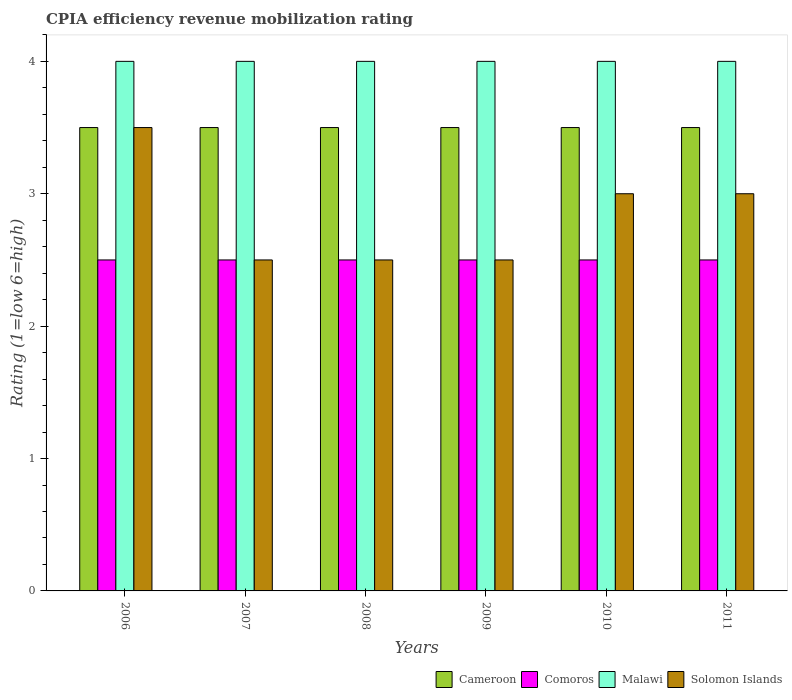Are the number of bars per tick equal to the number of legend labels?
Provide a short and direct response. Yes. Are the number of bars on each tick of the X-axis equal?
Offer a terse response. Yes. What is the label of the 1st group of bars from the left?
Ensure brevity in your answer.  2006. Across all years, what is the maximum CPIA rating in Comoros?
Your answer should be compact. 2.5. Across all years, what is the minimum CPIA rating in Malawi?
Give a very brief answer. 4. In which year was the CPIA rating in Malawi maximum?
Give a very brief answer. 2006. In which year was the CPIA rating in Cameroon minimum?
Keep it short and to the point. 2006. What is the total CPIA rating in Solomon Islands in the graph?
Your answer should be compact. 17. What is the difference between the CPIA rating in Cameroon in 2008 and that in 2011?
Your answer should be compact. 0. What is the difference between the CPIA rating in Comoros in 2011 and the CPIA rating in Cameroon in 2007?
Your response must be concise. -1. What is the ratio of the CPIA rating in Solomon Islands in 2006 to that in 2010?
Your answer should be very brief. 1.17. Is the difference between the CPIA rating in Solomon Islands in 2006 and 2007 greater than the difference between the CPIA rating in Cameroon in 2006 and 2007?
Your response must be concise. Yes. What is the difference between the highest and the lowest CPIA rating in Comoros?
Offer a very short reply. 0. Is the sum of the CPIA rating in Comoros in 2008 and 2010 greater than the maximum CPIA rating in Malawi across all years?
Give a very brief answer. Yes. What does the 2nd bar from the left in 2010 represents?
Offer a very short reply. Comoros. What does the 4th bar from the right in 2008 represents?
Your answer should be very brief. Cameroon. Is it the case that in every year, the sum of the CPIA rating in Comoros and CPIA rating in Malawi is greater than the CPIA rating in Cameroon?
Offer a terse response. Yes. Are all the bars in the graph horizontal?
Your answer should be very brief. No. How many years are there in the graph?
Provide a short and direct response. 6. Does the graph contain any zero values?
Make the answer very short. No. Does the graph contain grids?
Give a very brief answer. No. Where does the legend appear in the graph?
Keep it short and to the point. Bottom right. How are the legend labels stacked?
Make the answer very short. Horizontal. What is the title of the graph?
Keep it short and to the point. CPIA efficiency revenue mobilization rating. What is the Rating (1=low 6=high) of Cameroon in 2006?
Your response must be concise. 3.5. What is the Rating (1=low 6=high) in Solomon Islands in 2006?
Your response must be concise. 3.5. What is the Rating (1=low 6=high) in Cameroon in 2008?
Provide a succinct answer. 3.5. What is the Rating (1=low 6=high) in Comoros in 2008?
Provide a succinct answer. 2.5. What is the Rating (1=low 6=high) in Solomon Islands in 2008?
Keep it short and to the point. 2.5. What is the Rating (1=low 6=high) in Comoros in 2009?
Your response must be concise. 2.5. What is the Rating (1=low 6=high) of Solomon Islands in 2009?
Keep it short and to the point. 2.5. What is the Rating (1=low 6=high) of Comoros in 2010?
Offer a very short reply. 2.5. What is the Rating (1=low 6=high) of Solomon Islands in 2010?
Keep it short and to the point. 3. What is the Rating (1=low 6=high) of Comoros in 2011?
Provide a succinct answer. 2.5. What is the Rating (1=low 6=high) in Malawi in 2011?
Your answer should be very brief. 4. What is the Rating (1=low 6=high) of Solomon Islands in 2011?
Your answer should be very brief. 3. Across all years, what is the maximum Rating (1=low 6=high) in Malawi?
Your answer should be compact. 4. Across all years, what is the maximum Rating (1=low 6=high) of Solomon Islands?
Offer a terse response. 3.5. Across all years, what is the minimum Rating (1=low 6=high) in Cameroon?
Give a very brief answer. 3.5. Across all years, what is the minimum Rating (1=low 6=high) of Malawi?
Make the answer very short. 4. Across all years, what is the minimum Rating (1=low 6=high) in Solomon Islands?
Offer a very short reply. 2.5. What is the total Rating (1=low 6=high) in Malawi in the graph?
Offer a terse response. 24. What is the total Rating (1=low 6=high) of Solomon Islands in the graph?
Your answer should be compact. 17. What is the difference between the Rating (1=low 6=high) in Cameroon in 2006 and that in 2007?
Your answer should be compact. 0. What is the difference between the Rating (1=low 6=high) of Comoros in 2006 and that in 2007?
Your answer should be very brief. 0. What is the difference between the Rating (1=low 6=high) in Malawi in 2006 and that in 2007?
Offer a terse response. 0. What is the difference between the Rating (1=low 6=high) of Cameroon in 2006 and that in 2008?
Offer a very short reply. 0. What is the difference between the Rating (1=low 6=high) in Comoros in 2006 and that in 2008?
Offer a very short reply. 0. What is the difference between the Rating (1=low 6=high) in Malawi in 2006 and that in 2008?
Your answer should be compact. 0. What is the difference between the Rating (1=low 6=high) of Solomon Islands in 2006 and that in 2008?
Your answer should be very brief. 1. What is the difference between the Rating (1=low 6=high) in Comoros in 2006 and that in 2010?
Make the answer very short. 0. What is the difference between the Rating (1=low 6=high) of Malawi in 2006 and that in 2010?
Ensure brevity in your answer.  0. What is the difference between the Rating (1=low 6=high) in Comoros in 2006 and that in 2011?
Ensure brevity in your answer.  0. What is the difference between the Rating (1=low 6=high) in Malawi in 2006 and that in 2011?
Make the answer very short. 0. What is the difference between the Rating (1=low 6=high) of Malawi in 2007 and that in 2008?
Ensure brevity in your answer.  0. What is the difference between the Rating (1=low 6=high) of Solomon Islands in 2007 and that in 2008?
Give a very brief answer. 0. What is the difference between the Rating (1=low 6=high) in Solomon Islands in 2007 and that in 2009?
Your response must be concise. 0. What is the difference between the Rating (1=low 6=high) of Comoros in 2007 and that in 2010?
Give a very brief answer. 0. What is the difference between the Rating (1=low 6=high) of Malawi in 2007 and that in 2010?
Offer a terse response. 0. What is the difference between the Rating (1=low 6=high) in Cameroon in 2007 and that in 2011?
Make the answer very short. 0. What is the difference between the Rating (1=low 6=high) in Comoros in 2007 and that in 2011?
Offer a very short reply. 0. What is the difference between the Rating (1=low 6=high) of Malawi in 2007 and that in 2011?
Your response must be concise. 0. What is the difference between the Rating (1=low 6=high) in Cameroon in 2008 and that in 2010?
Make the answer very short. 0. What is the difference between the Rating (1=low 6=high) in Comoros in 2008 and that in 2010?
Offer a very short reply. 0. What is the difference between the Rating (1=low 6=high) in Solomon Islands in 2008 and that in 2010?
Offer a very short reply. -0.5. What is the difference between the Rating (1=low 6=high) in Cameroon in 2008 and that in 2011?
Make the answer very short. 0. What is the difference between the Rating (1=low 6=high) in Comoros in 2008 and that in 2011?
Your answer should be very brief. 0. What is the difference between the Rating (1=low 6=high) in Solomon Islands in 2008 and that in 2011?
Keep it short and to the point. -0.5. What is the difference between the Rating (1=low 6=high) in Malawi in 2009 and that in 2010?
Keep it short and to the point. 0. What is the difference between the Rating (1=low 6=high) in Cameroon in 2009 and that in 2011?
Make the answer very short. 0. What is the difference between the Rating (1=low 6=high) of Comoros in 2010 and that in 2011?
Ensure brevity in your answer.  0. What is the difference between the Rating (1=low 6=high) in Malawi in 2010 and that in 2011?
Provide a short and direct response. 0. What is the difference between the Rating (1=low 6=high) in Cameroon in 2006 and the Rating (1=low 6=high) in Malawi in 2007?
Your answer should be compact. -0.5. What is the difference between the Rating (1=low 6=high) in Comoros in 2006 and the Rating (1=low 6=high) in Malawi in 2007?
Make the answer very short. -1.5. What is the difference between the Rating (1=low 6=high) of Comoros in 2006 and the Rating (1=low 6=high) of Solomon Islands in 2007?
Provide a succinct answer. 0. What is the difference between the Rating (1=low 6=high) in Cameroon in 2006 and the Rating (1=low 6=high) in Comoros in 2008?
Offer a very short reply. 1. What is the difference between the Rating (1=low 6=high) of Cameroon in 2006 and the Rating (1=low 6=high) of Malawi in 2008?
Keep it short and to the point. -0.5. What is the difference between the Rating (1=low 6=high) in Cameroon in 2006 and the Rating (1=low 6=high) in Solomon Islands in 2008?
Ensure brevity in your answer.  1. What is the difference between the Rating (1=low 6=high) of Comoros in 2006 and the Rating (1=low 6=high) of Malawi in 2008?
Your response must be concise. -1.5. What is the difference between the Rating (1=low 6=high) of Comoros in 2006 and the Rating (1=low 6=high) of Solomon Islands in 2008?
Make the answer very short. 0. What is the difference between the Rating (1=low 6=high) of Malawi in 2006 and the Rating (1=low 6=high) of Solomon Islands in 2008?
Keep it short and to the point. 1.5. What is the difference between the Rating (1=low 6=high) in Cameroon in 2006 and the Rating (1=low 6=high) in Malawi in 2009?
Offer a terse response. -0.5. What is the difference between the Rating (1=low 6=high) of Cameroon in 2006 and the Rating (1=low 6=high) of Solomon Islands in 2009?
Offer a very short reply. 1. What is the difference between the Rating (1=low 6=high) in Comoros in 2006 and the Rating (1=low 6=high) in Solomon Islands in 2009?
Offer a very short reply. 0. What is the difference between the Rating (1=low 6=high) of Cameroon in 2006 and the Rating (1=low 6=high) of Comoros in 2010?
Your response must be concise. 1. What is the difference between the Rating (1=low 6=high) in Cameroon in 2006 and the Rating (1=low 6=high) in Malawi in 2010?
Provide a succinct answer. -0.5. What is the difference between the Rating (1=low 6=high) in Comoros in 2006 and the Rating (1=low 6=high) in Solomon Islands in 2010?
Make the answer very short. -0.5. What is the difference between the Rating (1=low 6=high) in Malawi in 2006 and the Rating (1=low 6=high) in Solomon Islands in 2010?
Keep it short and to the point. 1. What is the difference between the Rating (1=low 6=high) of Cameroon in 2006 and the Rating (1=low 6=high) of Comoros in 2011?
Provide a short and direct response. 1. What is the difference between the Rating (1=low 6=high) of Cameroon in 2006 and the Rating (1=low 6=high) of Solomon Islands in 2011?
Provide a short and direct response. 0.5. What is the difference between the Rating (1=low 6=high) of Comoros in 2006 and the Rating (1=low 6=high) of Malawi in 2011?
Your answer should be compact. -1.5. What is the difference between the Rating (1=low 6=high) of Malawi in 2006 and the Rating (1=low 6=high) of Solomon Islands in 2011?
Provide a succinct answer. 1. What is the difference between the Rating (1=low 6=high) in Cameroon in 2007 and the Rating (1=low 6=high) in Malawi in 2008?
Keep it short and to the point. -0.5. What is the difference between the Rating (1=low 6=high) of Cameroon in 2007 and the Rating (1=low 6=high) of Solomon Islands in 2008?
Your answer should be compact. 1. What is the difference between the Rating (1=low 6=high) of Comoros in 2007 and the Rating (1=low 6=high) of Malawi in 2008?
Offer a very short reply. -1.5. What is the difference between the Rating (1=low 6=high) of Malawi in 2007 and the Rating (1=low 6=high) of Solomon Islands in 2008?
Your answer should be compact. 1.5. What is the difference between the Rating (1=low 6=high) in Cameroon in 2007 and the Rating (1=low 6=high) in Comoros in 2009?
Make the answer very short. 1. What is the difference between the Rating (1=low 6=high) in Cameroon in 2007 and the Rating (1=low 6=high) in Malawi in 2009?
Give a very brief answer. -0.5. What is the difference between the Rating (1=low 6=high) in Cameroon in 2007 and the Rating (1=low 6=high) in Solomon Islands in 2009?
Your answer should be very brief. 1. What is the difference between the Rating (1=low 6=high) in Comoros in 2007 and the Rating (1=low 6=high) in Malawi in 2009?
Give a very brief answer. -1.5. What is the difference between the Rating (1=low 6=high) in Comoros in 2007 and the Rating (1=low 6=high) in Solomon Islands in 2009?
Keep it short and to the point. 0. What is the difference between the Rating (1=low 6=high) in Malawi in 2007 and the Rating (1=low 6=high) in Solomon Islands in 2009?
Your response must be concise. 1.5. What is the difference between the Rating (1=low 6=high) in Cameroon in 2007 and the Rating (1=low 6=high) in Malawi in 2010?
Your answer should be very brief. -0.5. What is the difference between the Rating (1=low 6=high) of Cameroon in 2007 and the Rating (1=low 6=high) of Solomon Islands in 2010?
Your answer should be very brief. 0.5. What is the difference between the Rating (1=low 6=high) of Comoros in 2007 and the Rating (1=low 6=high) of Malawi in 2010?
Your answer should be compact. -1.5. What is the difference between the Rating (1=low 6=high) of Comoros in 2007 and the Rating (1=low 6=high) of Solomon Islands in 2010?
Offer a terse response. -0.5. What is the difference between the Rating (1=low 6=high) in Malawi in 2007 and the Rating (1=low 6=high) in Solomon Islands in 2010?
Your answer should be compact. 1. What is the difference between the Rating (1=low 6=high) in Cameroon in 2007 and the Rating (1=low 6=high) in Comoros in 2011?
Your answer should be compact. 1. What is the difference between the Rating (1=low 6=high) in Cameroon in 2007 and the Rating (1=low 6=high) in Solomon Islands in 2011?
Your response must be concise. 0.5. What is the difference between the Rating (1=low 6=high) of Comoros in 2007 and the Rating (1=low 6=high) of Solomon Islands in 2011?
Your answer should be very brief. -0.5. What is the difference between the Rating (1=low 6=high) in Cameroon in 2008 and the Rating (1=low 6=high) in Comoros in 2009?
Provide a succinct answer. 1. What is the difference between the Rating (1=low 6=high) of Cameroon in 2008 and the Rating (1=low 6=high) of Malawi in 2009?
Your response must be concise. -0.5. What is the difference between the Rating (1=low 6=high) in Comoros in 2008 and the Rating (1=low 6=high) in Malawi in 2009?
Your answer should be very brief. -1.5. What is the difference between the Rating (1=low 6=high) in Cameroon in 2008 and the Rating (1=low 6=high) in Malawi in 2010?
Offer a terse response. -0.5. What is the difference between the Rating (1=low 6=high) of Comoros in 2008 and the Rating (1=low 6=high) of Malawi in 2010?
Offer a terse response. -1.5. What is the difference between the Rating (1=low 6=high) in Cameroon in 2008 and the Rating (1=low 6=high) in Malawi in 2011?
Provide a succinct answer. -0.5. What is the difference between the Rating (1=low 6=high) of Comoros in 2008 and the Rating (1=low 6=high) of Solomon Islands in 2011?
Offer a very short reply. -0.5. What is the difference between the Rating (1=low 6=high) in Cameroon in 2009 and the Rating (1=low 6=high) in Comoros in 2010?
Make the answer very short. 1. What is the difference between the Rating (1=low 6=high) of Cameroon in 2009 and the Rating (1=low 6=high) of Malawi in 2010?
Provide a short and direct response. -0.5. What is the difference between the Rating (1=low 6=high) in Comoros in 2009 and the Rating (1=low 6=high) in Malawi in 2010?
Your answer should be compact. -1.5. What is the difference between the Rating (1=low 6=high) of Cameroon in 2009 and the Rating (1=low 6=high) of Comoros in 2011?
Offer a terse response. 1. What is the difference between the Rating (1=low 6=high) of Cameroon in 2009 and the Rating (1=low 6=high) of Solomon Islands in 2011?
Provide a short and direct response. 0.5. What is the difference between the Rating (1=low 6=high) of Comoros in 2009 and the Rating (1=low 6=high) of Malawi in 2011?
Ensure brevity in your answer.  -1.5. What is the difference between the Rating (1=low 6=high) in Comoros in 2009 and the Rating (1=low 6=high) in Solomon Islands in 2011?
Offer a terse response. -0.5. What is the difference between the Rating (1=low 6=high) of Cameroon in 2010 and the Rating (1=low 6=high) of Solomon Islands in 2011?
Keep it short and to the point. 0.5. What is the difference between the Rating (1=low 6=high) in Comoros in 2010 and the Rating (1=low 6=high) in Malawi in 2011?
Make the answer very short. -1.5. What is the difference between the Rating (1=low 6=high) in Malawi in 2010 and the Rating (1=low 6=high) in Solomon Islands in 2011?
Offer a very short reply. 1. What is the average Rating (1=low 6=high) of Malawi per year?
Provide a short and direct response. 4. What is the average Rating (1=low 6=high) of Solomon Islands per year?
Make the answer very short. 2.83. In the year 2006, what is the difference between the Rating (1=low 6=high) of Cameroon and Rating (1=low 6=high) of Solomon Islands?
Offer a terse response. 0. In the year 2006, what is the difference between the Rating (1=low 6=high) in Malawi and Rating (1=low 6=high) in Solomon Islands?
Offer a terse response. 0.5. In the year 2007, what is the difference between the Rating (1=low 6=high) in Cameroon and Rating (1=low 6=high) in Comoros?
Offer a terse response. 1. In the year 2007, what is the difference between the Rating (1=low 6=high) in Cameroon and Rating (1=low 6=high) in Solomon Islands?
Ensure brevity in your answer.  1. In the year 2007, what is the difference between the Rating (1=low 6=high) of Comoros and Rating (1=low 6=high) of Solomon Islands?
Give a very brief answer. 0. In the year 2008, what is the difference between the Rating (1=low 6=high) in Cameroon and Rating (1=low 6=high) in Comoros?
Provide a short and direct response. 1. In the year 2008, what is the difference between the Rating (1=low 6=high) of Cameroon and Rating (1=low 6=high) of Solomon Islands?
Offer a very short reply. 1. In the year 2008, what is the difference between the Rating (1=low 6=high) of Comoros and Rating (1=low 6=high) of Solomon Islands?
Your answer should be compact. 0. In the year 2009, what is the difference between the Rating (1=low 6=high) of Cameroon and Rating (1=low 6=high) of Solomon Islands?
Provide a succinct answer. 1. In the year 2009, what is the difference between the Rating (1=low 6=high) of Comoros and Rating (1=low 6=high) of Malawi?
Offer a very short reply. -1.5. In the year 2009, what is the difference between the Rating (1=low 6=high) in Malawi and Rating (1=low 6=high) in Solomon Islands?
Give a very brief answer. 1.5. In the year 2010, what is the difference between the Rating (1=low 6=high) in Cameroon and Rating (1=low 6=high) in Malawi?
Your answer should be compact. -0.5. In the year 2010, what is the difference between the Rating (1=low 6=high) in Comoros and Rating (1=low 6=high) in Malawi?
Offer a terse response. -1.5. In the year 2010, what is the difference between the Rating (1=low 6=high) of Comoros and Rating (1=low 6=high) of Solomon Islands?
Your answer should be very brief. -0.5. In the year 2011, what is the difference between the Rating (1=low 6=high) of Cameroon and Rating (1=low 6=high) of Malawi?
Make the answer very short. -0.5. In the year 2011, what is the difference between the Rating (1=low 6=high) of Comoros and Rating (1=low 6=high) of Solomon Islands?
Provide a succinct answer. -0.5. What is the ratio of the Rating (1=low 6=high) of Cameroon in 2006 to that in 2007?
Your answer should be very brief. 1. What is the ratio of the Rating (1=low 6=high) of Comoros in 2006 to that in 2007?
Keep it short and to the point. 1. What is the ratio of the Rating (1=low 6=high) in Malawi in 2006 to that in 2007?
Your response must be concise. 1. What is the ratio of the Rating (1=low 6=high) of Comoros in 2006 to that in 2008?
Give a very brief answer. 1. What is the ratio of the Rating (1=low 6=high) in Malawi in 2006 to that in 2009?
Keep it short and to the point. 1. What is the ratio of the Rating (1=low 6=high) of Solomon Islands in 2006 to that in 2009?
Your response must be concise. 1.4. What is the ratio of the Rating (1=low 6=high) of Cameroon in 2006 to that in 2010?
Make the answer very short. 1. What is the ratio of the Rating (1=low 6=high) in Malawi in 2006 to that in 2010?
Provide a succinct answer. 1. What is the ratio of the Rating (1=low 6=high) in Solomon Islands in 2006 to that in 2010?
Make the answer very short. 1.17. What is the ratio of the Rating (1=low 6=high) in Comoros in 2006 to that in 2011?
Make the answer very short. 1. What is the ratio of the Rating (1=low 6=high) of Solomon Islands in 2006 to that in 2011?
Offer a terse response. 1.17. What is the ratio of the Rating (1=low 6=high) of Comoros in 2007 to that in 2008?
Your answer should be very brief. 1. What is the ratio of the Rating (1=low 6=high) in Malawi in 2007 to that in 2008?
Your response must be concise. 1. What is the ratio of the Rating (1=low 6=high) in Solomon Islands in 2007 to that in 2008?
Offer a terse response. 1. What is the ratio of the Rating (1=low 6=high) in Comoros in 2007 to that in 2009?
Offer a terse response. 1. What is the ratio of the Rating (1=low 6=high) in Cameroon in 2007 to that in 2010?
Offer a very short reply. 1. What is the ratio of the Rating (1=low 6=high) of Solomon Islands in 2007 to that in 2010?
Your answer should be compact. 0.83. What is the ratio of the Rating (1=low 6=high) of Cameroon in 2007 to that in 2011?
Ensure brevity in your answer.  1. What is the ratio of the Rating (1=low 6=high) of Comoros in 2007 to that in 2011?
Provide a short and direct response. 1. What is the ratio of the Rating (1=low 6=high) of Solomon Islands in 2007 to that in 2011?
Your response must be concise. 0.83. What is the ratio of the Rating (1=low 6=high) of Cameroon in 2008 to that in 2009?
Offer a very short reply. 1. What is the ratio of the Rating (1=low 6=high) of Comoros in 2008 to that in 2009?
Ensure brevity in your answer.  1. What is the ratio of the Rating (1=low 6=high) of Malawi in 2008 to that in 2009?
Provide a succinct answer. 1. What is the ratio of the Rating (1=low 6=high) of Solomon Islands in 2008 to that in 2009?
Make the answer very short. 1. What is the ratio of the Rating (1=low 6=high) in Cameroon in 2008 to that in 2010?
Offer a terse response. 1. What is the ratio of the Rating (1=low 6=high) of Malawi in 2008 to that in 2010?
Offer a very short reply. 1. What is the ratio of the Rating (1=low 6=high) of Solomon Islands in 2008 to that in 2010?
Your response must be concise. 0.83. What is the ratio of the Rating (1=low 6=high) of Malawi in 2008 to that in 2011?
Provide a short and direct response. 1. What is the ratio of the Rating (1=low 6=high) in Cameroon in 2009 to that in 2010?
Give a very brief answer. 1. What is the ratio of the Rating (1=low 6=high) in Comoros in 2009 to that in 2010?
Offer a terse response. 1. What is the ratio of the Rating (1=low 6=high) in Solomon Islands in 2009 to that in 2011?
Your answer should be very brief. 0.83. What is the ratio of the Rating (1=low 6=high) in Malawi in 2010 to that in 2011?
Offer a very short reply. 1. What is the difference between the highest and the lowest Rating (1=low 6=high) in Malawi?
Make the answer very short. 0. What is the difference between the highest and the lowest Rating (1=low 6=high) of Solomon Islands?
Your response must be concise. 1. 